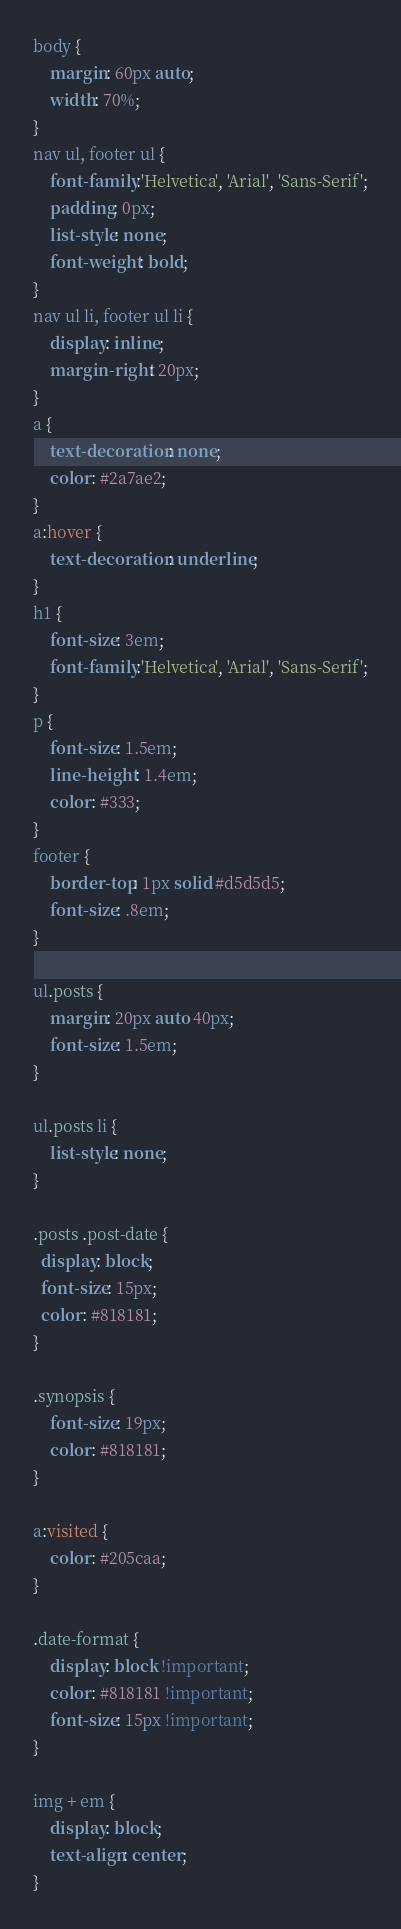Convert code to text. <code><loc_0><loc_0><loc_500><loc_500><_CSS_>body {
    margin: 60px auto;
    width: 70%;
}
nav ul, footer ul {
    font-family:'Helvetica', 'Arial', 'Sans-Serif';
    padding: 0px;
    list-style: none;
    font-weight: bold;
}
nav ul li, footer ul li {
    display: inline;
    margin-right: 20px;
}
a {
    text-decoration: none;
    color: #2a7ae2;
}
a:hover {
    text-decoration: underline;
}
h1 {
    font-size: 3em;
    font-family:'Helvetica', 'Arial', 'Sans-Serif';
}
p {
    font-size: 1.5em;
    line-height: 1.4em;
    color: #333;
}
footer {
    border-top: 1px solid #d5d5d5;
    font-size: .8em;
}

ul.posts {
    margin: 20px auto 40px;
    font-size: 1.5em;
}

ul.posts li {
    list-style: none;
}

.posts .post-date {
  display: block;
  font-size: 15px;
  color: #818181;
}

.synopsis {
    font-size: 19px;
    color: #818181;
}

a:visited {
    color: #205caa;
}

.date-format {
    display: block !important;
    color: #818181 !important;
    font-size: 15px !important;
}

img + em {
    display: block;
    text-align: center;
}
</code> 